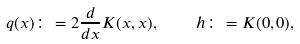<formula> <loc_0><loc_0><loc_500><loc_500>q ( x ) \colon = 2 \frac { d } { d x } K ( x , x ) , \quad h \colon = K ( 0 , 0 ) ,</formula> 